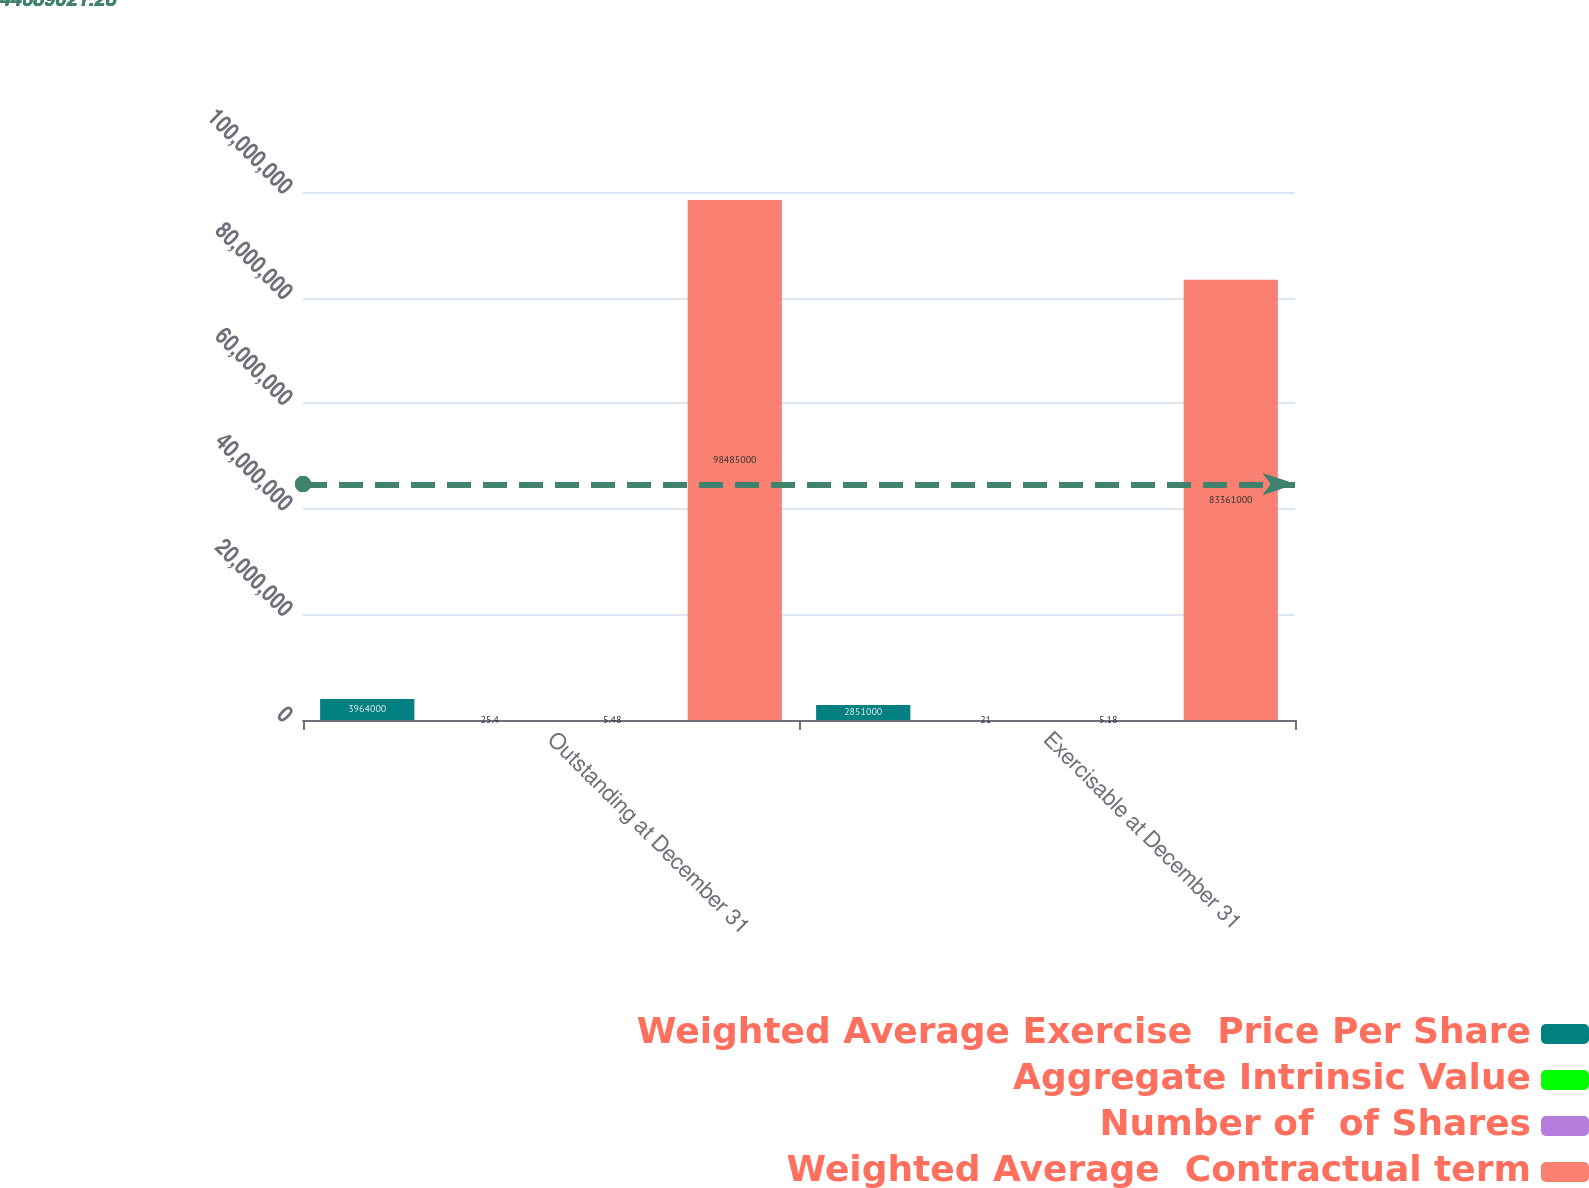Convert chart. <chart><loc_0><loc_0><loc_500><loc_500><stacked_bar_chart><ecel><fcel>Outstanding at December 31<fcel>Exercisable at December 31<nl><fcel>Weighted Average Exercise  Price Per Share<fcel>3.964e+06<fcel>2.851e+06<nl><fcel>Aggregate Intrinsic Value<fcel>25.4<fcel>21<nl><fcel>Number of  of Shares<fcel>5.48<fcel>5.18<nl><fcel>Weighted Average  Contractual term<fcel>9.8485e+07<fcel>8.3361e+07<nl></chart> 